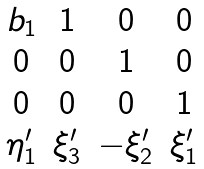<formula> <loc_0><loc_0><loc_500><loc_500>\begin{matrix} b _ { 1 } & 1 & 0 & 0 \\ 0 & 0 & 1 & 0 \\ 0 & 0 & 0 & 1 \\ \eta ^ { \prime } _ { 1 } & \xi _ { 3 } ^ { \prime } & - \xi _ { 2 } ^ { \prime } & \xi _ { 1 } ^ { \prime } \end{matrix}</formula> 